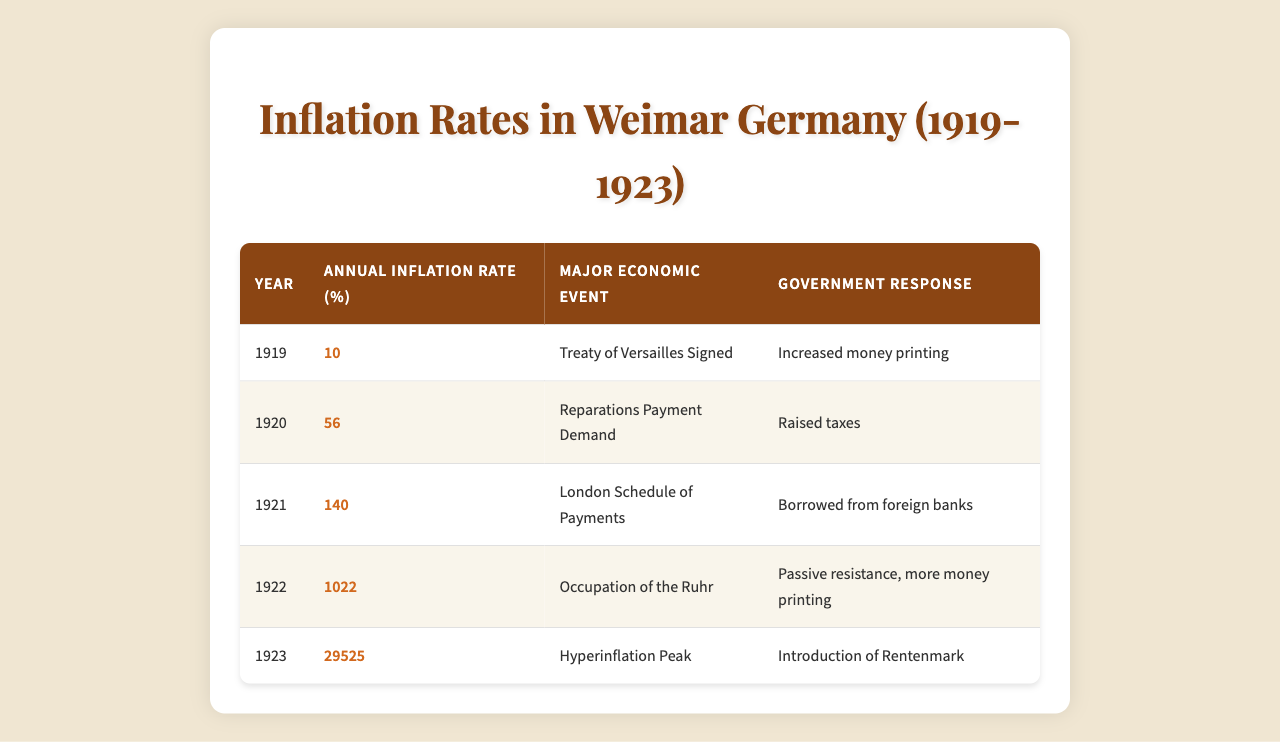What was the highest annual inflation rate recorded in Weimar Germany from 1919 to 1923? By examining the table, we see that 29525% is the highest value listed under the "Annual Inflation Rate (%)" column, corresponding to the year 1923.
Answer: 29525% Which economic event coincided with the introduction of the Rentenmark? The introduction of the Rentenmark occurred in 1923, which is listed as the "Hyperinflation Peak" in the table.
Answer: Hyperinflation Peak How much did the annual inflation rate increase from 1920 to 1921? The annual inflation rate in 1920 was 56%, and in 1921 it was 140%. To find the increase, we subtract: 140 - 56 = 84.
Answer: 84% Was the inflation rate above 100% in 1922? Yes, the table shows the inflation rate in 1922 was 1022%, which is above 100%.
Answer: Yes What was the average annual inflation rate from 1919 to 1923? We add the inflation rates for each year: 10 + 56 + 140 + 1022 + 29525 = 30653. There are 5 years, so we divide to find the average: 30653 / 5 = 6130.6.
Answer: 6130.6% What government response was common during both 1922 and 1923? Both years involved increases in money printing as a government response. In 1922, it was specifically in reaction to the occupation of the Ruhr, and in 1923, it was associated with hyperinflation.
Answer: Increased money printing How did the government's approach shift from 1919 to 1923 regarding economic responses? Initially, in 1919, the response was to increase money printing. By 1923, as hyperinflation peaked, the government introduced a new currency (Rentenmark), indicating a shift towards stabilizing the economy rather than just printing more money.
Answer: Shifted to introducing Rentenmark What was the annual inflation rate in the year of the occupation of the Ruhr? The annual inflation rate during the occupation of the Ruhr in 1922 was 1022%.
Answer: 1022% Was there a year where the inflation rate exceeded 1000%? Yes, the inflation rate in 1923 was remarkably high at 29525%, exceeding 1000%.
Answer: Yes How many times did the inflation rate increase from 1919 to 1922? The inflation rate increased from 10% in 1919 to 1022% in 1922. To find the increase: 1022 / 10 = 102.2, indicating the rate increased by a factor of approximately 102 times.
Answer: Approximately 102 times Which year experienced a significant economic event linked to reparations payments? The year 1921 experienced the London Schedule of Payments linked to reparations, with an inflation rate of 140%.
Answer: 1921 